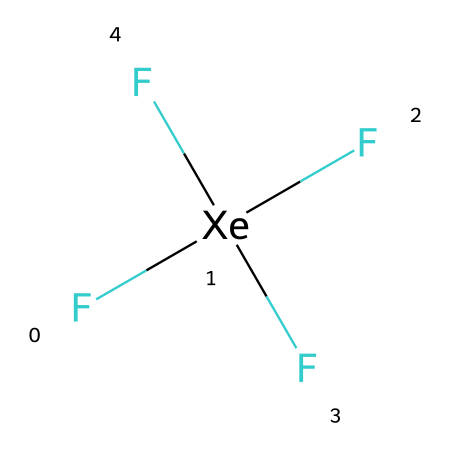What is the chemical name of this compound? The SMILES representation corresponds to a compound consisting of xenon and four fluorine atoms arranged around the xenon atom. The chemical name for this structure is xenon tetrafluoride.
Answer: xenon tetrafluoride How many fluorine atoms are present in the structure? The SMILES notation indicates that there are four fluorine atoms (F) bonded to a central xenon atom (Xe). Counting the number of F in the representation confirms that there are a total of four.
Answer: four What is the hybridization of the xenon atom in this compound? The structure shows that the xenon atom is surrounded by four fluorine atoms and has one lone pair. This arrangement leads to an sp³d hybridization to accommodate the five electron pairs (four bonding and one lone pair).
Answer: sp³d Does xenon tetrafluoride follow the octet rule? In this structure, the xenon atom is able to expand its valence shell beyond an octet, as it has more than eight electrons surrounding it, consisting of four bonding pairs with fluorine and a lone pair. Thus, xenon tetrafluoride is a hypervalent compound.
Answer: no What type of molecular geometry does xenon tetrafluoride exhibit? Given that the central xenon atom has four bonding pairs and one lone pair, the molecular geometry can be described as square pyramidal based on VSEPR theory, which considers both coordination number and the presence of lone pairs.
Answer: square pyramidal 